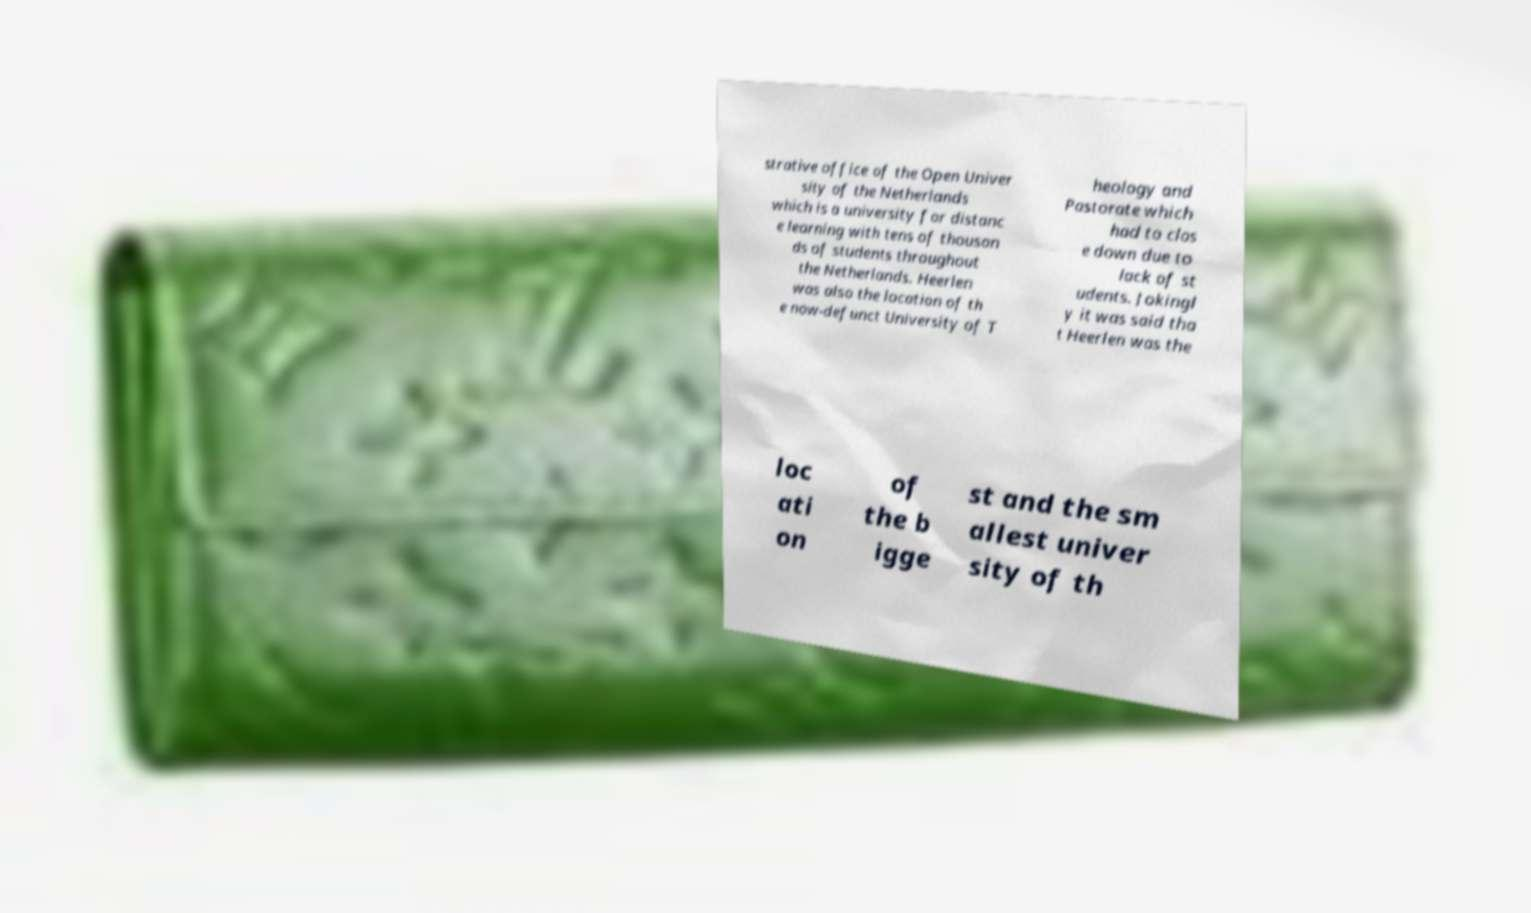Can you read and provide the text displayed in the image?This photo seems to have some interesting text. Can you extract and type it out for me? strative office of the Open Univer sity of the Netherlands which is a university for distanc e learning with tens of thousan ds of students throughout the Netherlands. Heerlen was also the location of th e now-defunct University of T heology and Pastorate which had to clos e down due to lack of st udents. Jokingl y it was said tha t Heerlen was the loc ati on of the b igge st and the sm allest univer sity of th 